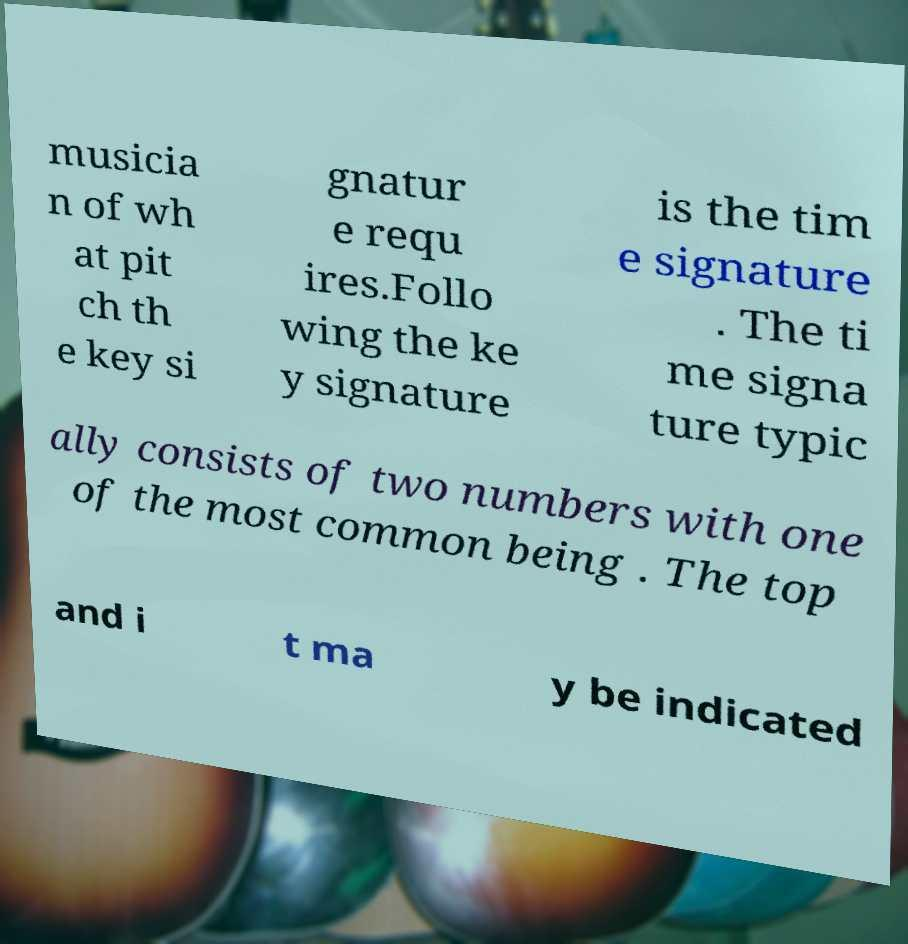Could you extract and type out the text from this image? musicia n of wh at pit ch th e key si gnatur e requ ires.Follo wing the ke y signature is the tim e signature . The ti me signa ture typic ally consists of two numbers with one of the most common being . The top and i t ma y be indicated 